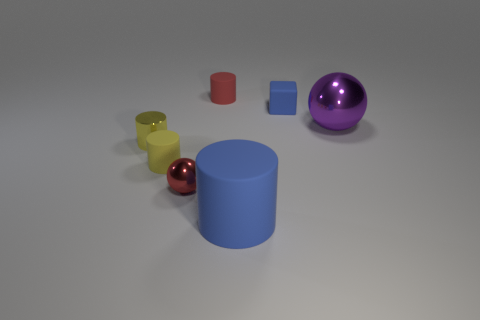What can you infer about the sizes of the objects relative to each other? Upon observation, we can infer that the objects come in a variety of sizes. The large blue cylinder is the tallest and widest among the objects displayed. The yellow cylinder is the next largest, although it is both shorter and narrower than the blue one. The purple and small red spheres are roughly the same size, while the small blue cube is the smallest object in terms of height but with equal dimensions in width and depth. This variety in size provides an interesting study in contrasts and comparisons among the objects. 